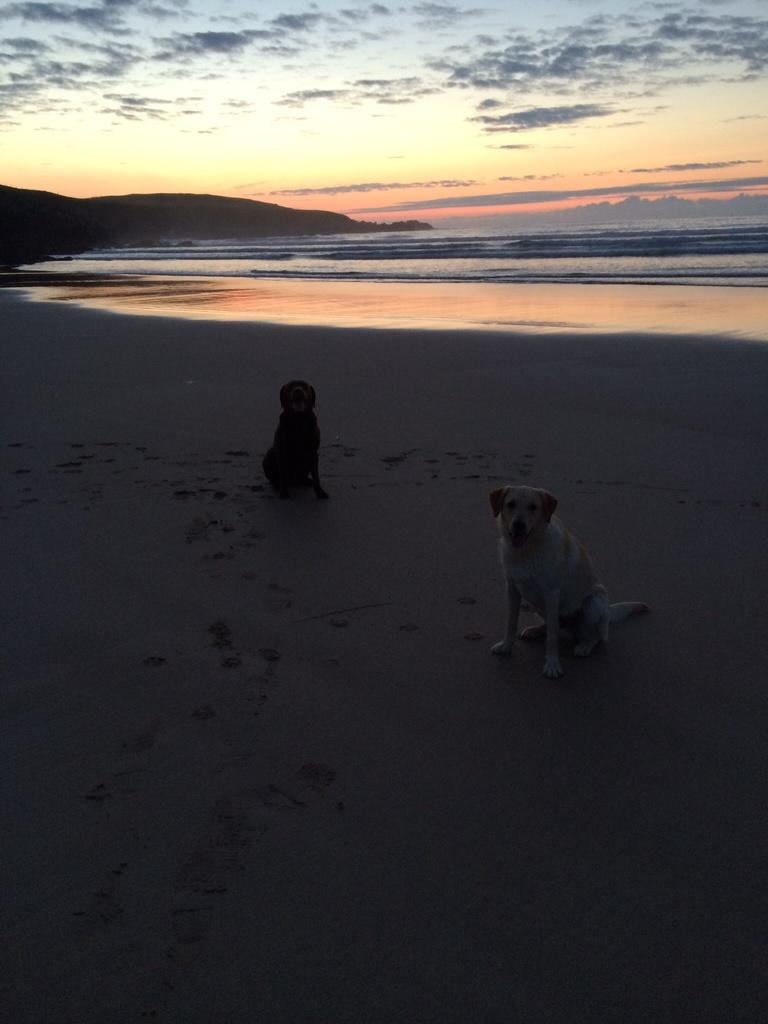What animals are in the center of the image? There are two dogs in the center of the image. What can be seen in the background of the image? Sky, clouds, water, and a hill are visible in the background of the image. What type of baby is playing in the field in the image? There is no baby or field present in the image; it features two dogs and a background with sky, clouds, water, and a hill. What is the relation between the two dogs in the image? The provided facts do not give any information about the relationship between the two dogs. 